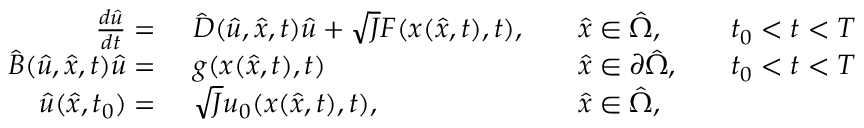<formula> <loc_0><loc_0><loc_500><loc_500>\begin{array} { r l r l r l } { \frac { d \hat { u } } { d t } = \ } & \hat { D } ( \hat { u } , \hat { x } , t ) \hat { u } + \sqrt { J } F ( x ( \hat { x } , t ) , t ) , } & \hat { x } \in \hat { \Omega } , } & t _ { 0 } < t < T } \\ { \hat { B } ( \hat { u } , \hat { x } , t ) \hat { u } = \ } & g ( x ( \hat { x } , t ) , t ) } & \hat { x } \in \partial \hat { \Omega } , } & t _ { 0 } < t < T } \\ { \hat { u } ( \hat { x } , t _ { 0 } ) = \ } & \sqrt { J } u _ { 0 } ( x ( \hat { x } , t ) , t ) , } & \hat { x } \in \hat { \Omega } , } \end{array}</formula> 